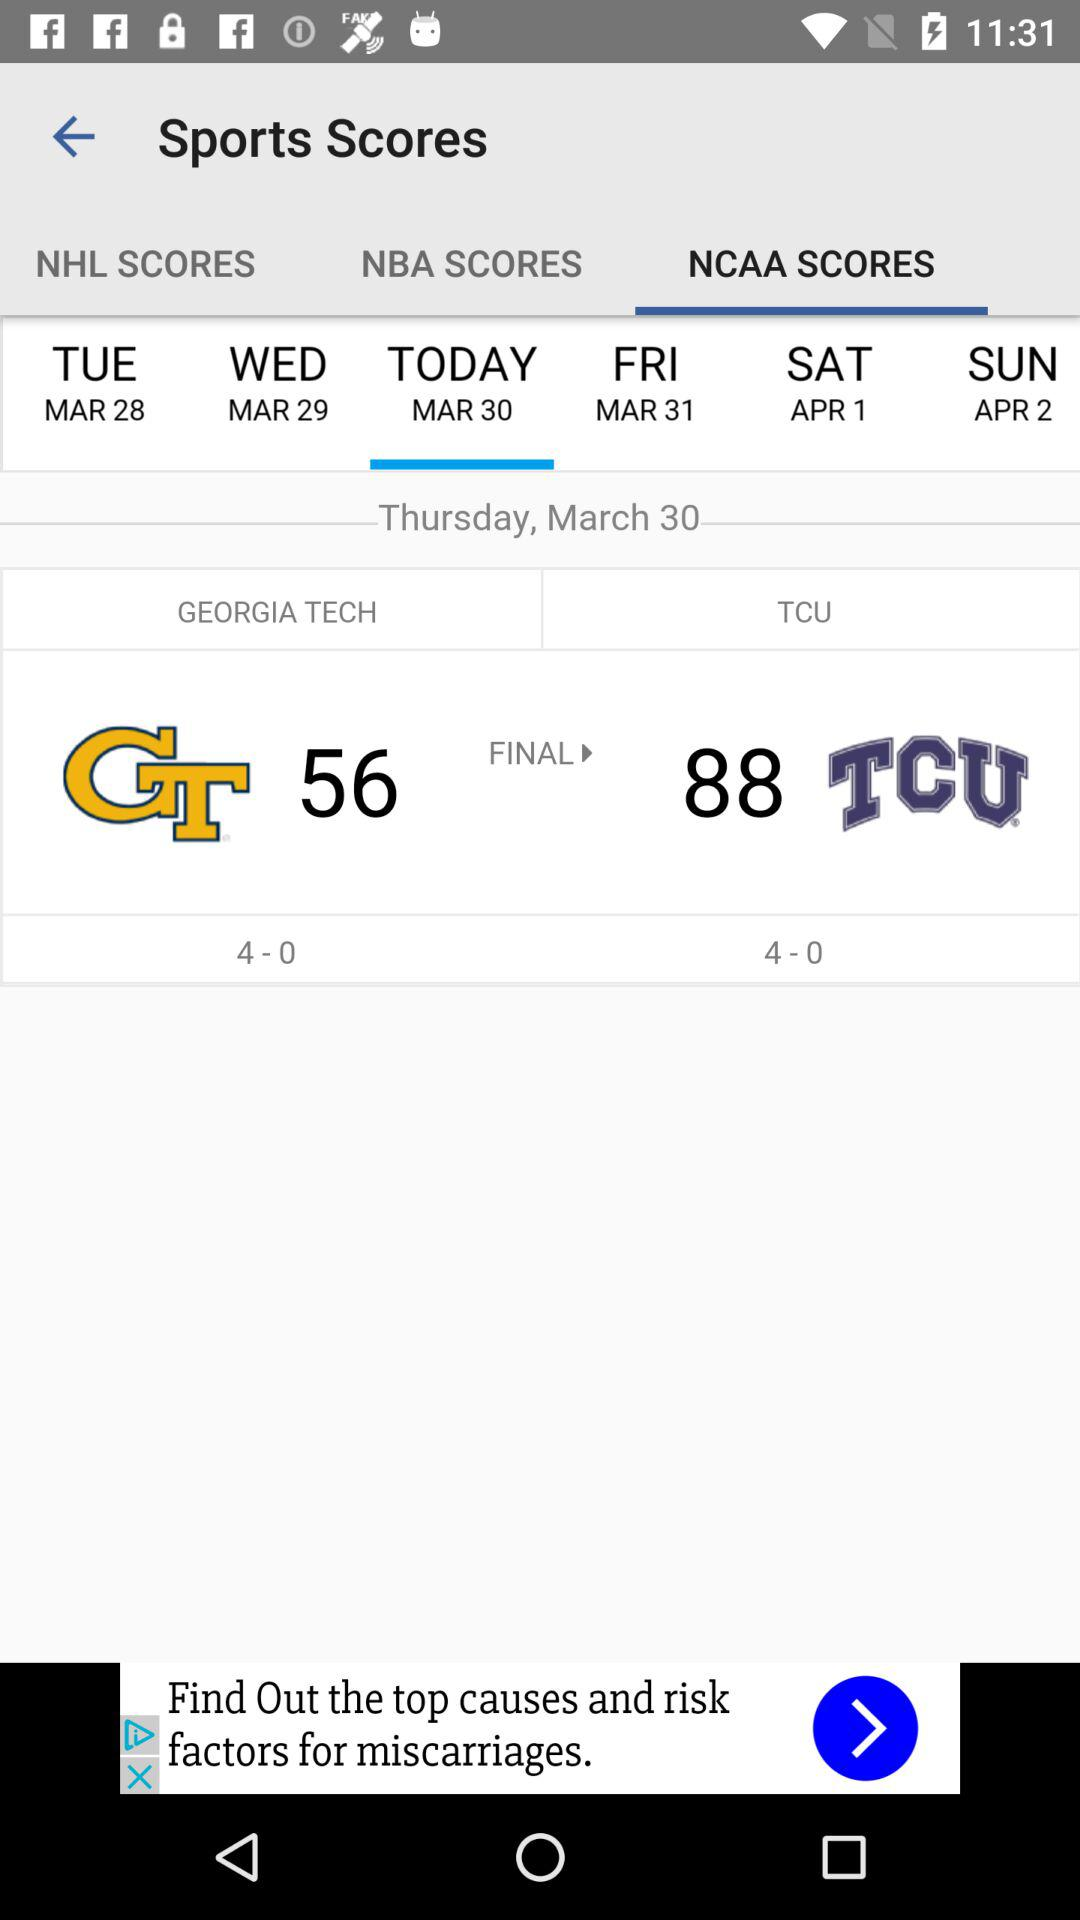For what date is the score showing? The date is Thursday, March 30. 